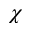Convert formula to latex. <formula><loc_0><loc_0><loc_500><loc_500>\chi</formula> 